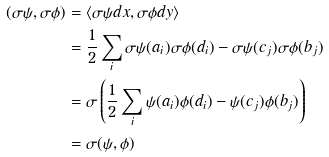<formula> <loc_0><loc_0><loc_500><loc_500>( \sigma \psi , \sigma \phi ) & = \langle \sigma \psi d x , \sigma \phi d y \rangle \\ & = \frac { 1 } { 2 } \sum _ { i } \sigma \psi ( a _ { i } ) \sigma \phi ( d _ { i } ) - \sigma \psi ( c _ { j } ) \sigma \phi ( b _ { j } ) \\ & = \sigma \left ( \frac { 1 } { 2 } \sum _ { i } \psi ( a _ { i } ) \phi ( d _ { i } ) - \psi ( c _ { j } ) \phi ( b _ { j } ) \right ) \\ & = \sigma ( \psi , \phi )</formula> 